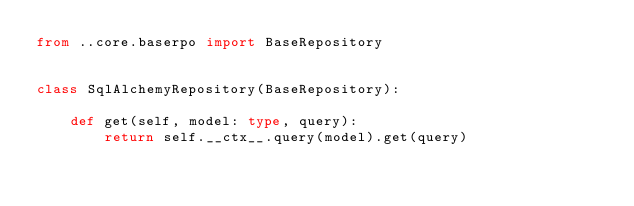Convert code to text. <code><loc_0><loc_0><loc_500><loc_500><_Python_>from ..core.baserpo import BaseRepository


class SqlAlchemyRepository(BaseRepository):

    def get(self, model: type, query):
        return self.__ctx__.query(model).get(query)</code> 